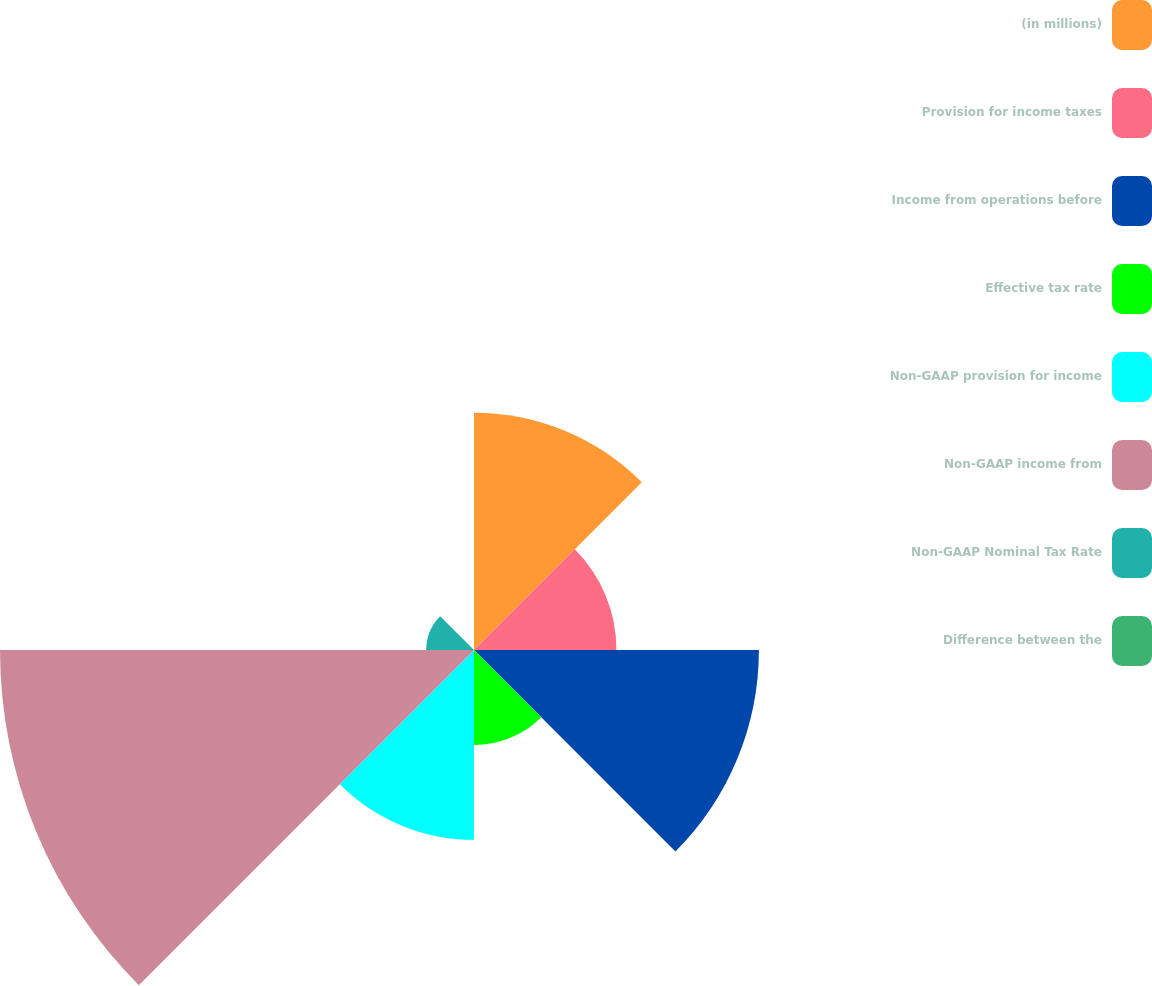<chart> <loc_0><loc_0><loc_500><loc_500><pie_chart><fcel>(in millions)<fcel>Provision for income taxes<fcel>Income from operations before<fcel>Effective tax rate<fcel>Non-GAAP provision for income<fcel>Non-GAAP income from<fcel>Non-GAAP Nominal Tax Rate<fcel>Difference between the<nl><fcel>16.12%<fcel>9.68%<fcel>19.36%<fcel>6.46%<fcel>12.9%<fcel>32.21%<fcel>3.25%<fcel>0.03%<nl></chart> 